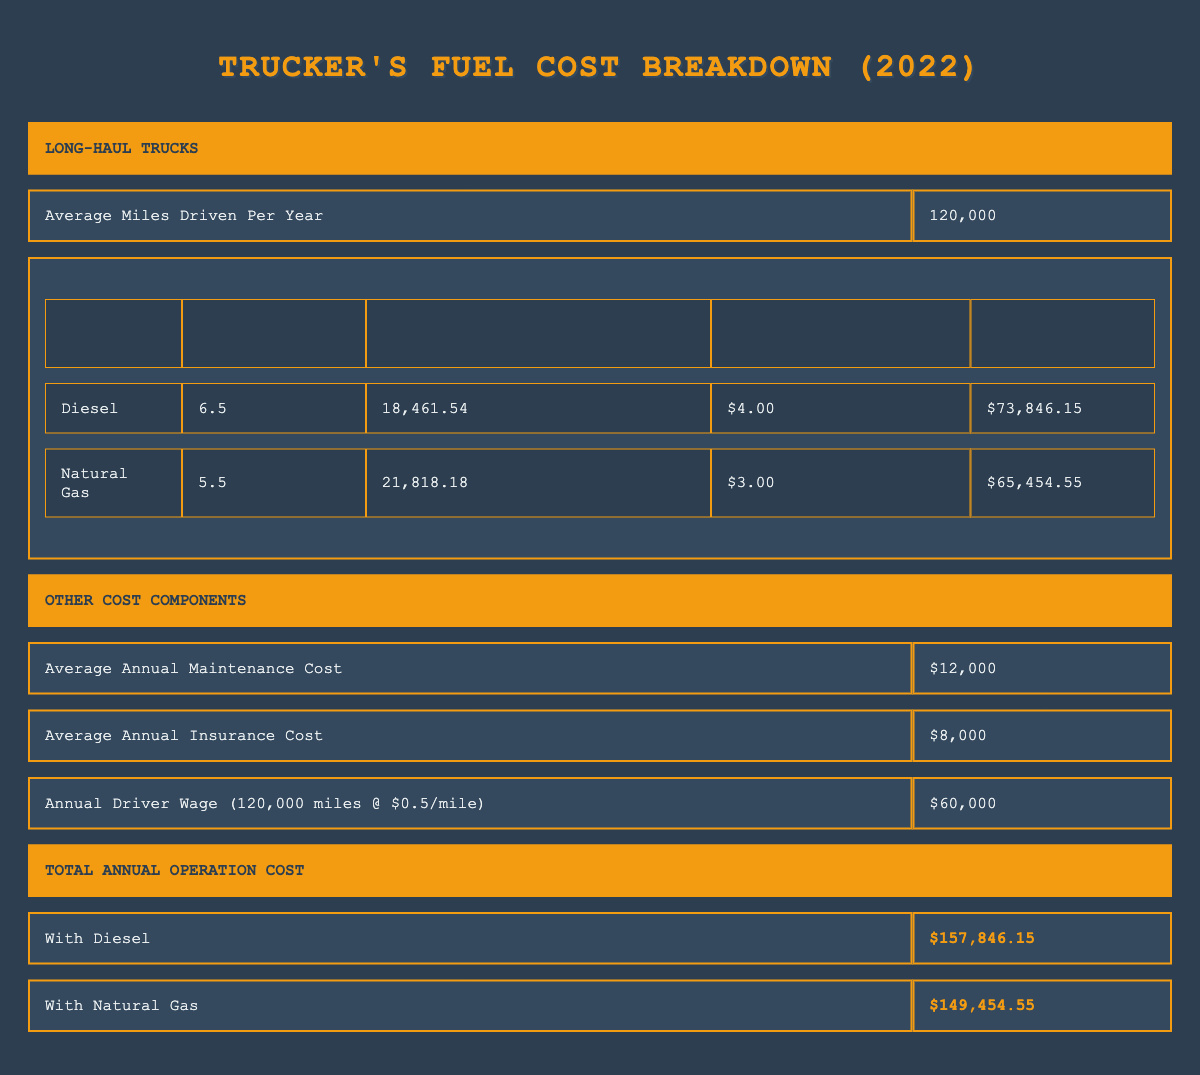What is the average miles driven per year by long-haul trucks? The table directly states that the average miles driven per year by long-haul trucks is 120,000.
Answer: 120,000 How much is the annual fuel cost for diesel? The table specifies that the annual fuel cost for diesel is $73,846.15.
Answer: $73,846.15 Is the average price per gallon of natural gas more than the average price per gallon of diesel? The table shows the average price per gallon of natural gas is $3.00 and diesel is $4.00. Since $3.00 is less than $4.00, the statement is false.
Answer: No What is the total cost of operation for a long-haul truck using natural gas? The table provides the total annual operation cost for natural gas as $149,454.55.
Answer: $149,454.55 What is the difference in annual fuel cost between diesel and natural gas? To find the difference, subtract the annual fuel cost of natural gas ($65,454.55) from diesel ($73,846.15): $73,846.15 - $65,454.55 = $8,391.60.
Answer: $8,391.60 What is the total of maintenance, insurance, and driver wages for one year? The table shows maintenance cost as $12,000, insurance as $8,000, and driver wages as $60,000. Adding those together: $12,000 + $8,000 + $60,000 = $80,000.
Answer: $80,000 Does the annual operation cost with diesel exceed $150,000? The total annual operation cost for diesel is provided as $157,846.15, which is greater than $150,000, indicating the statement is true.
Answer: Yes Which fuel type has a higher mileage per gallon based on the table? The fuel economy shows diesel has 6.5 miles per gallon while natural gas has 5.5 miles per gallon. Diesel has a higher mileage per gallon.
Answer: Diesel What is the total annual operation cost when using diesel trucks? According to the table, the total annual operation cost for diesel is $157,846.15.
Answer: $157,846.15 